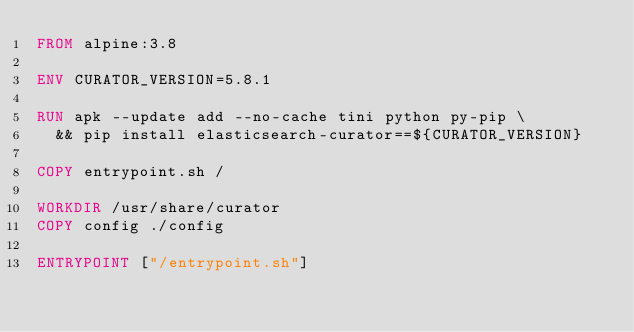<code> <loc_0><loc_0><loc_500><loc_500><_Dockerfile_>FROM alpine:3.8

ENV CURATOR_VERSION=5.8.1

RUN apk --update add --no-cache tini python py-pip \
  && pip install elasticsearch-curator==${CURATOR_VERSION}

COPY entrypoint.sh /

WORKDIR /usr/share/curator
COPY config ./config

ENTRYPOINT ["/entrypoint.sh"]
</code> 